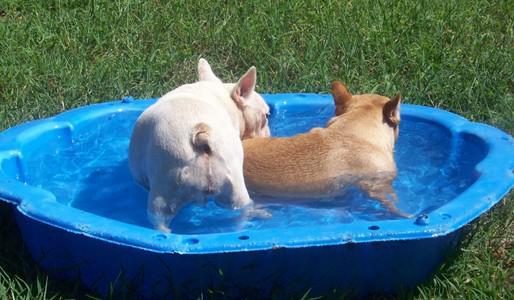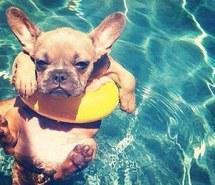The first image is the image on the left, the second image is the image on the right. Analyze the images presented: Is the assertion "The left image contains at least two dogs." valid? Answer yes or no. Yes. The first image is the image on the left, the second image is the image on the right. Analyze the images presented: Is the assertion "A stout brown-and-white bulldog is by himself in a blue kiddie pool in one image, and the other image shows a dog that is above the water of a larger swimming pool." valid? Answer yes or no. No. 